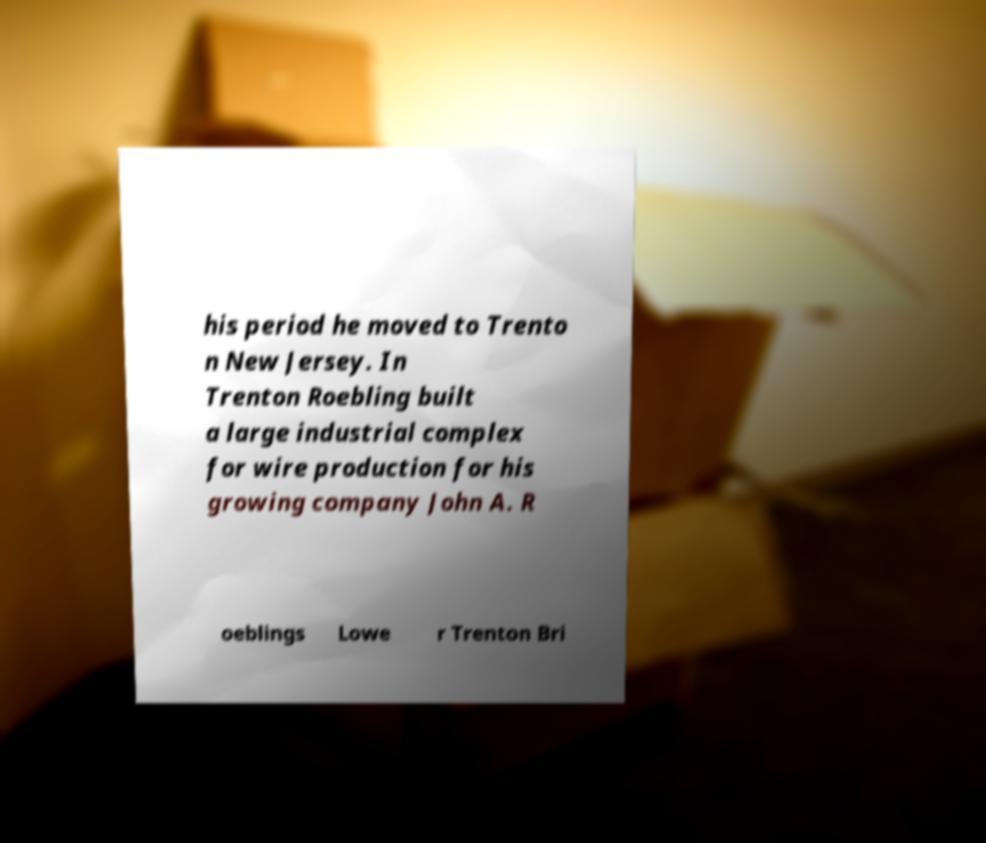Could you extract and type out the text from this image? his period he moved to Trento n New Jersey. In Trenton Roebling built a large industrial complex for wire production for his growing company John A. R oeblings Lowe r Trenton Bri 